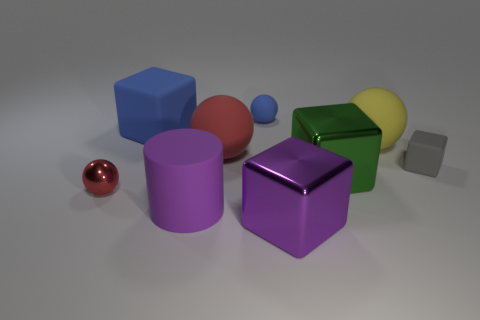Subtract all red balls. How many were subtracted if there are1red balls left? 1 Subtract 1 balls. How many balls are left? 3 Subtract all spheres. How many objects are left? 5 Subtract 0 gray balls. How many objects are left? 9 Subtract all big purple shiny cubes. Subtract all purple things. How many objects are left? 6 Add 4 blue rubber balls. How many blue rubber balls are left? 5 Add 3 purple metal spheres. How many purple metal spheres exist? 3 